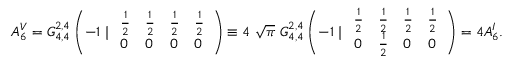<formula> <loc_0><loc_0><loc_500><loc_500>A _ { 6 } ^ { V } = G _ { 4 , 4 } ^ { 2 , 4 } \left ( - 1 | \begin{array} { l l l l } { \frac { 1 } { 2 } } & { \frac { 1 } { 2 } } & { \frac { 1 } { 2 } } & { \frac { 1 } { 2 } } \\ { 0 } & { 0 } & { 0 } & { 0 } \end{array} \right ) \equiv 4 \ { \sqrt { \pi } } \ G _ { 4 , 4 } ^ { 2 , 4 } \left ( - 1 | \begin{array} { l l l l } { \frac { 1 } { 2 } } & { \frac { 1 } { 2 } } & { \frac { 1 } { 2 } } & { \frac { 1 } { 2 } } \\ { 0 } & { \frac { 1 } { 2 } } & { 0 } & { 0 } \end{array} \right ) = 4 A _ { 6 } ^ { I } .</formula> 